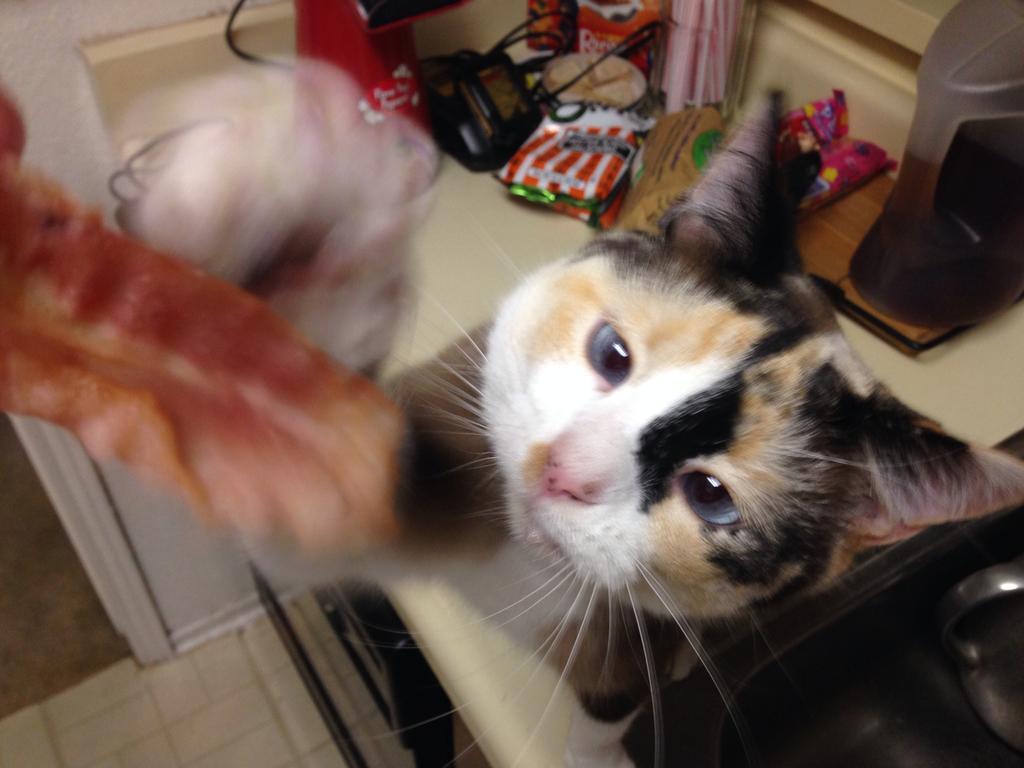Please provide a concise description of this image. In the center of the image there is a cat. In the background we can see covers, cloth, mat on the floor. 